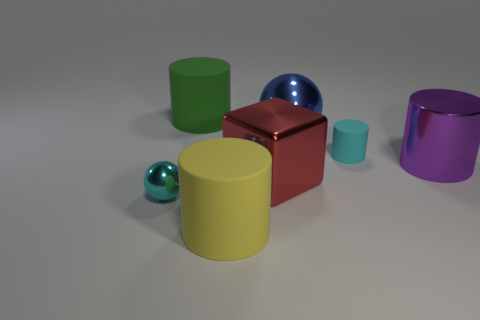Add 1 big yellow rubber cylinders. How many objects exist? 8 Subtract all cylinders. How many objects are left? 3 Subtract all big red rubber spheres. Subtract all large yellow things. How many objects are left? 6 Add 5 green matte objects. How many green matte objects are left? 6 Add 1 cyan blocks. How many cyan blocks exist? 1 Subtract 1 red cubes. How many objects are left? 6 